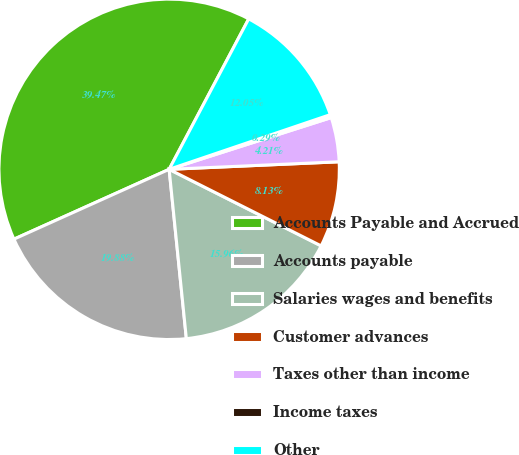Convert chart. <chart><loc_0><loc_0><loc_500><loc_500><pie_chart><fcel>Accounts Payable and Accrued<fcel>Accounts payable<fcel>Salaries wages and benefits<fcel>Customer advances<fcel>Taxes other than income<fcel>Income taxes<fcel>Other<nl><fcel>39.47%<fcel>19.88%<fcel>15.96%<fcel>8.13%<fcel>4.21%<fcel>0.29%<fcel>12.05%<nl></chart> 